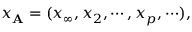Convert formula to latex. <formula><loc_0><loc_0><loc_500><loc_500>x _ { A } = ( x _ { \infty } , x _ { 2 } , \cdots , x _ { p } , \cdots ) ,</formula> 